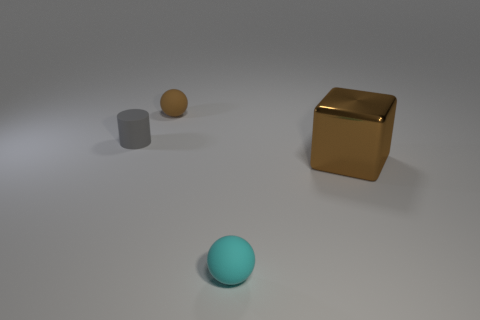Are there fewer gray things right of the brown sphere than objects that are behind the large object?
Keep it short and to the point. Yes. The large shiny cube is what color?
Offer a terse response. Brown. Is there a tiny rubber cylinder of the same color as the big shiny object?
Your answer should be compact. No. There is a small object that is behind the tiny matte thing to the left of the matte ball that is behind the brown shiny block; what is its shape?
Your answer should be compact. Sphere. There is a object in front of the big brown cube; what is its material?
Offer a very short reply. Rubber. There is a ball on the right side of the tiny rubber sphere on the left side of the tiny matte object that is in front of the large metal object; what size is it?
Give a very brief answer. Small. Do the cylinder and the brown object that is behind the rubber cylinder have the same size?
Keep it short and to the point. Yes. What is the color of the ball on the right side of the small brown ball?
Your response must be concise. Cyan. What is the shape of the tiny thing that is the same color as the large block?
Provide a short and direct response. Sphere. What is the shape of the brown object that is in front of the gray thing?
Provide a succinct answer. Cube. 